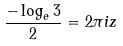<formula> <loc_0><loc_0><loc_500><loc_500>\frac { - \log _ { e } 3 } { 2 } = 2 \pi i z</formula> 